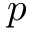<formula> <loc_0><loc_0><loc_500><loc_500>p</formula> 